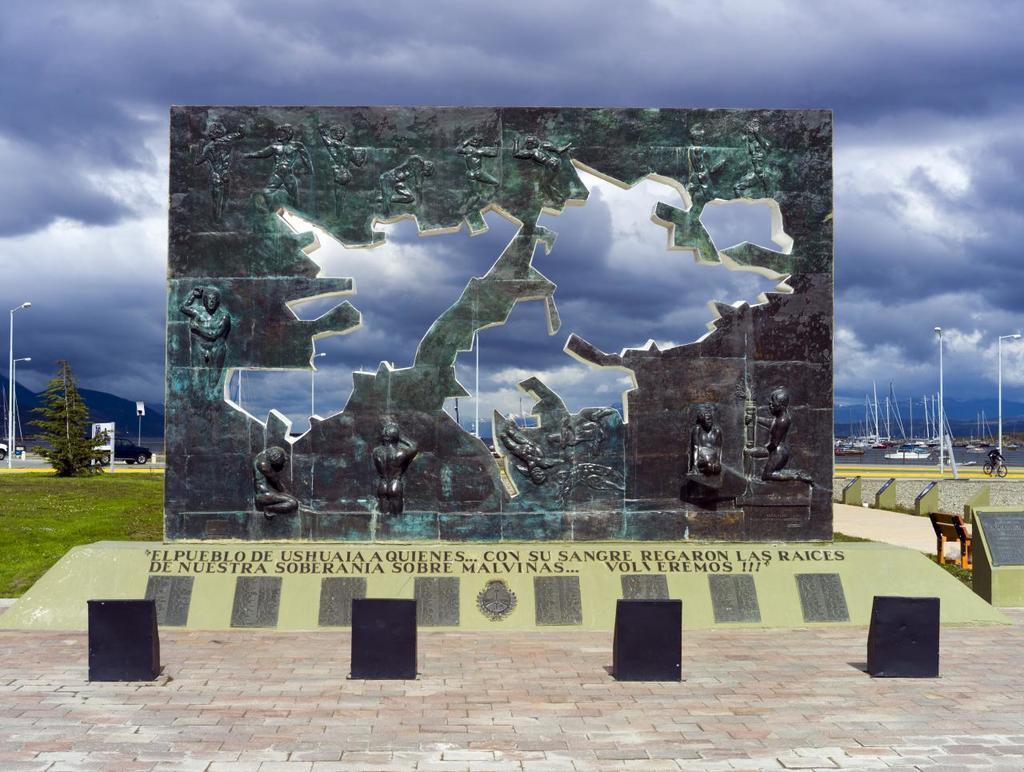Describe this image in one or two sentences. In this image we can see the mountains, one wall with sculptures, some black objects on the floor, some lights with poles, two boards with poles, some vehicles on the road, some poles, some boats on the water, one tree, some objects on the ground, some grass on the ground, one person riding bicycle, in the background there is the cloudy sky, some text and logo on the bottom of the wall. 